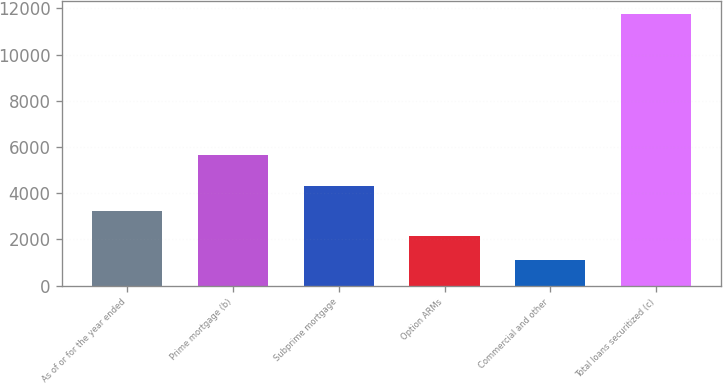<chart> <loc_0><loc_0><loc_500><loc_500><bar_chart><fcel>As of or for the year ended<fcel>Prime mortgage (b)<fcel>Subprime mortgage<fcel>Option ARMs<fcel>Commercial and other<fcel>Total loans securitized (c)<nl><fcel>3229.6<fcel>5650<fcel>4293.9<fcel>2165.3<fcel>1101<fcel>11744<nl></chart> 